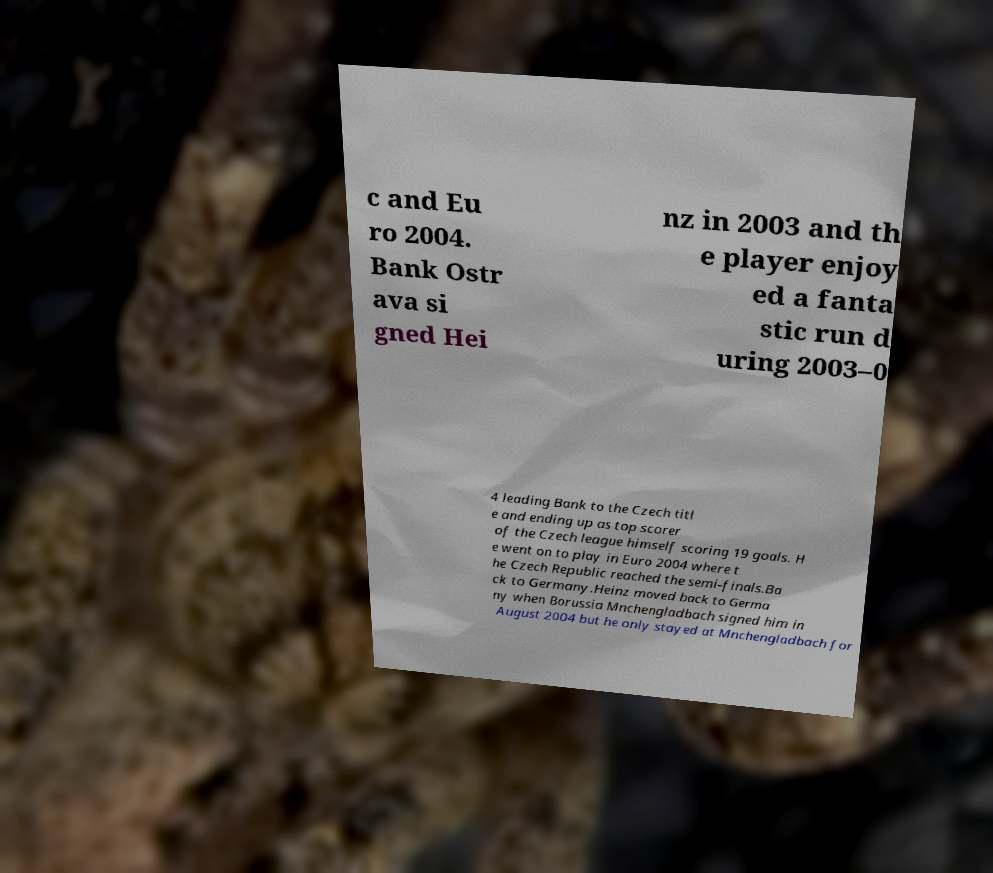For documentation purposes, I need the text within this image transcribed. Could you provide that? c and Eu ro 2004. Bank Ostr ava si gned Hei nz in 2003 and th e player enjoy ed a fanta stic run d uring 2003–0 4 leading Bank to the Czech titl e and ending up as top scorer of the Czech league himself scoring 19 goals. H e went on to play in Euro 2004 where t he Czech Republic reached the semi-finals.Ba ck to Germany.Heinz moved back to Germa ny when Borussia Mnchengladbach signed him in August 2004 but he only stayed at Mnchengladbach for 